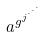Convert formula to latex. <formula><loc_0><loc_0><loc_500><loc_500>a ^ { g ^ { j ^ { \cdot ^ { \cdot ^ { \cdot } } } } }</formula> 